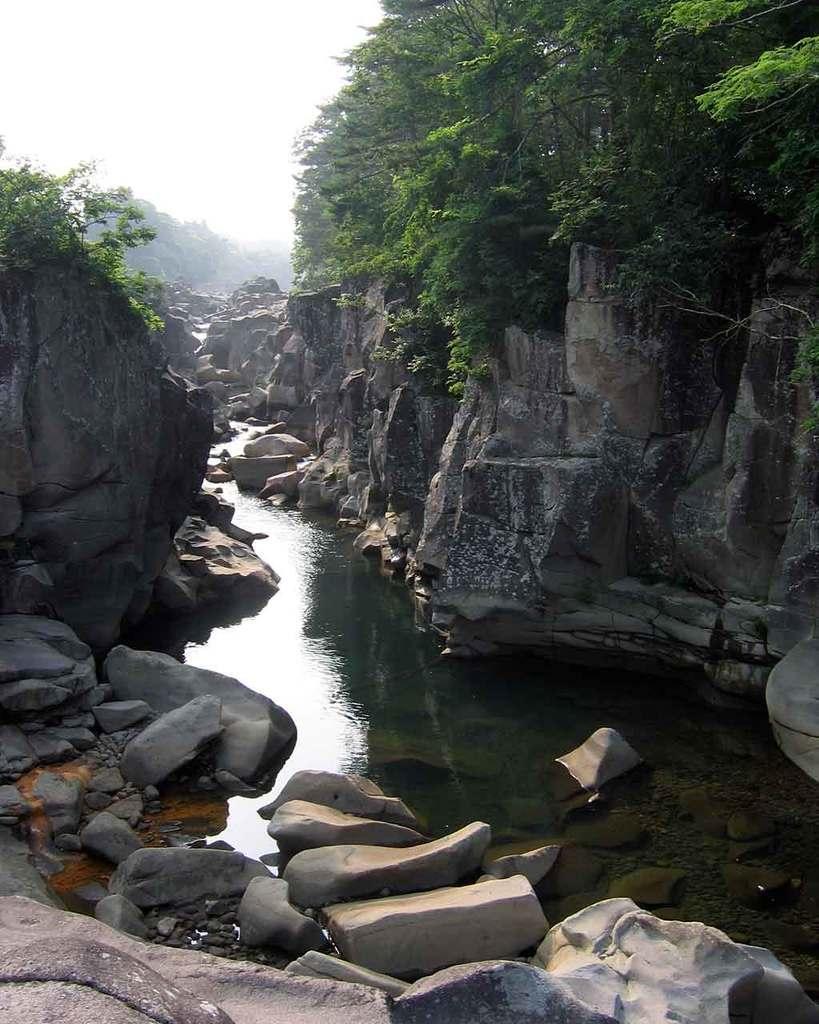Please provide a concise description of this image. In this image we can see lake, stones, rocks, trees and sky. 